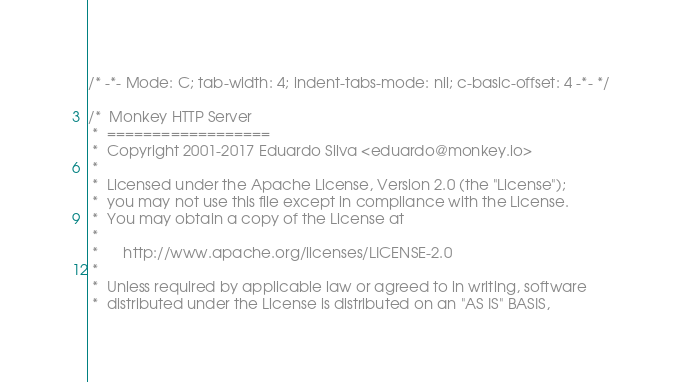Convert code to text. <code><loc_0><loc_0><loc_500><loc_500><_C_>/* -*- Mode: C; tab-width: 4; indent-tabs-mode: nil; c-basic-offset: 4 -*- */

/*  Monkey HTTP Server
 *  ==================
 *  Copyright 2001-2017 Eduardo Silva <eduardo@monkey.io>
 *
 *  Licensed under the Apache License, Version 2.0 (the "License");
 *  you may not use this file except in compliance with the License.
 *  You may obtain a copy of the License at
 *
 *      http://www.apache.org/licenses/LICENSE-2.0
 *
 *  Unless required by applicable law or agreed to in writing, software
 *  distributed under the License is distributed on an "AS IS" BASIS,</code> 